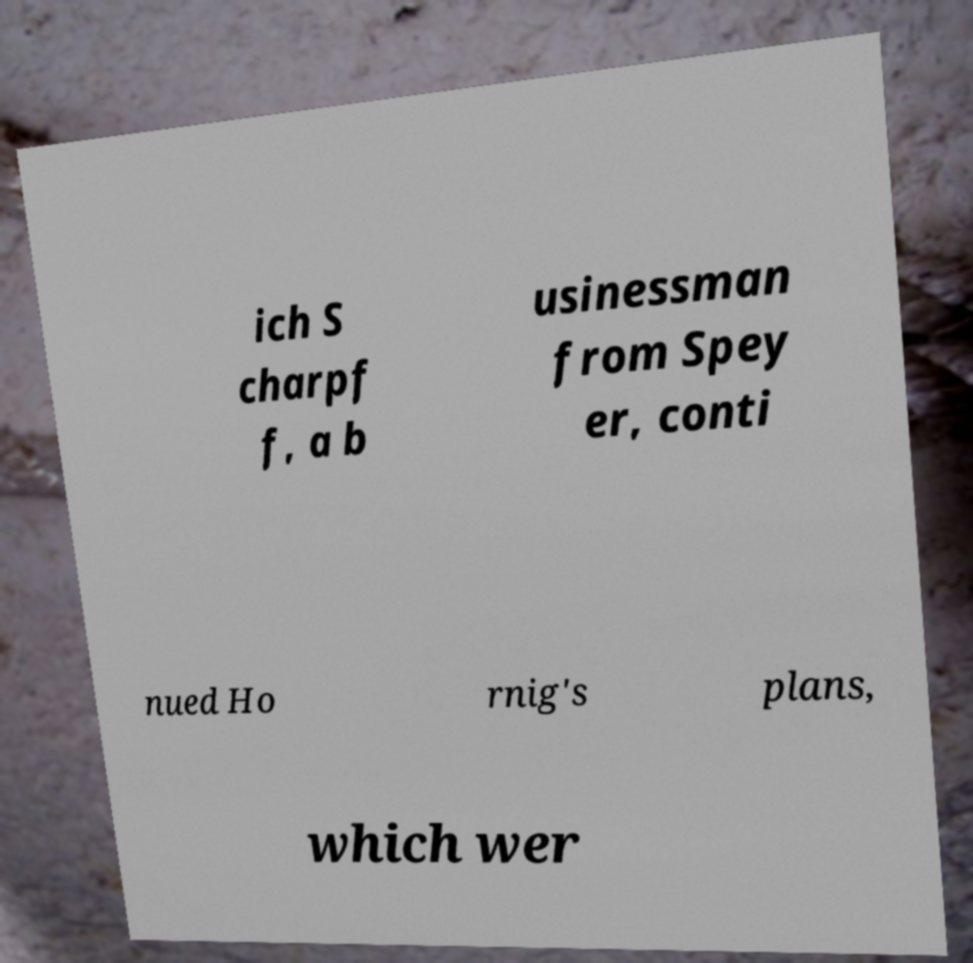Can you read and provide the text displayed in the image?This photo seems to have some interesting text. Can you extract and type it out for me? ich S charpf f, a b usinessman from Spey er, conti nued Ho rnig's plans, which wer 